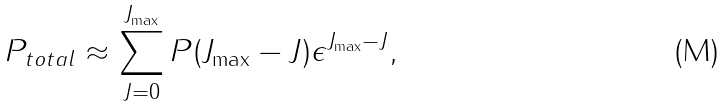<formula> <loc_0><loc_0><loc_500><loc_500>P _ { t o t a l } \approx \sum _ { J = 0 } ^ { J _ { \max } } P ( J _ { \max } - J ) \epsilon ^ { J _ { \max } - J } ,</formula> 